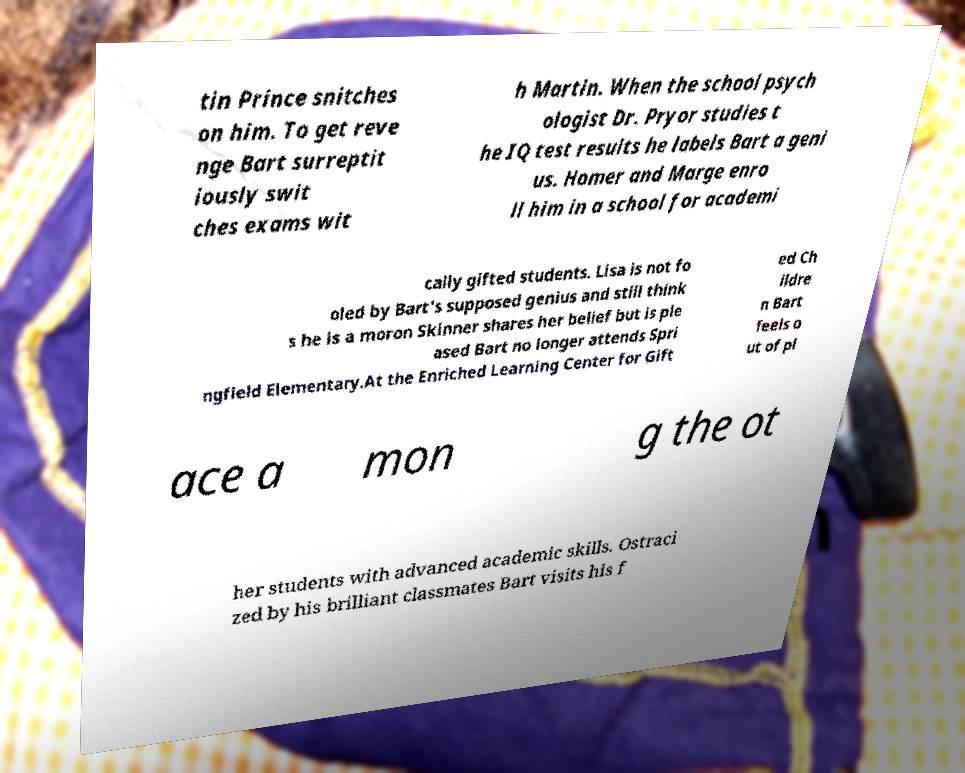There's text embedded in this image that I need extracted. Can you transcribe it verbatim? tin Prince snitches on him. To get reve nge Bart surreptit iously swit ches exams wit h Martin. When the school psych ologist Dr. Pryor studies t he IQ test results he labels Bart a geni us. Homer and Marge enro ll him in a school for academi cally gifted students. Lisa is not fo oled by Bart's supposed genius and still think s he is a moron Skinner shares her belief but is ple ased Bart no longer attends Spri ngfield Elementary.At the Enriched Learning Center for Gift ed Ch ildre n Bart feels o ut of pl ace a mon g the ot her students with advanced academic skills. Ostraci zed by his brilliant classmates Bart visits his f 